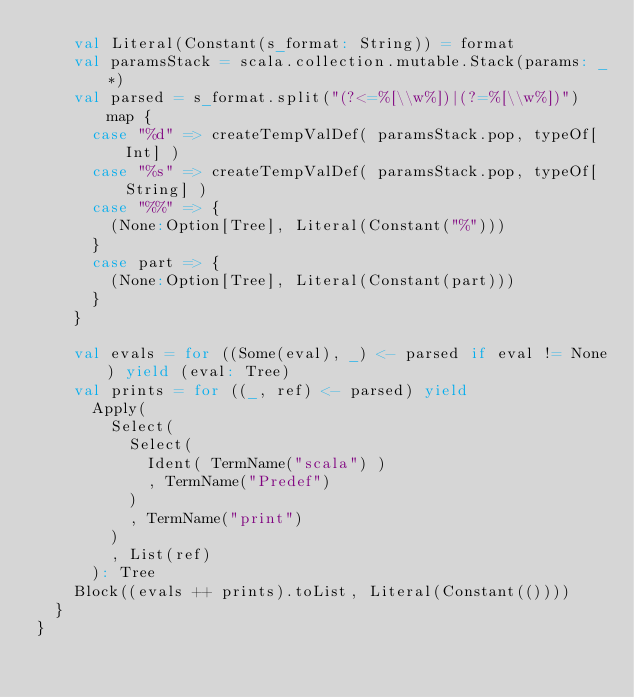Convert code to text. <code><loc_0><loc_0><loc_500><loc_500><_Scala_>    val Literal(Constant(s_format: String)) = format
    val paramsStack = scala.collection.mutable.Stack(params: _*)
    val parsed = s_format.split("(?<=%[\\w%])|(?=%[\\w%])") map {
      case "%d" => createTempValDef( paramsStack.pop, typeOf[Int] )
      case "%s" => createTempValDef( paramsStack.pop, typeOf[String] )
      case "%%" => {
        (None:Option[Tree], Literal(Constant("%")))
      }
      case part => {
        (None:Option[Tree], Literal(Constant(part)))
      }
    }

    val evals = for ((Some(eval), _) <- parsed if eval != None) yield (eval: Tree)
    val prints = for ((_, ref) <- parsed) yield
      Apply(
        Select(
          Select(
            Ident( TermName("scala") )
            , TermName("Predef")
          )
          , TermName("print")
        )
        , List(ref)
      ): Tree
    Block((evals ++ prints).toList, Literal(Constant(())))
  }
}
</code> 